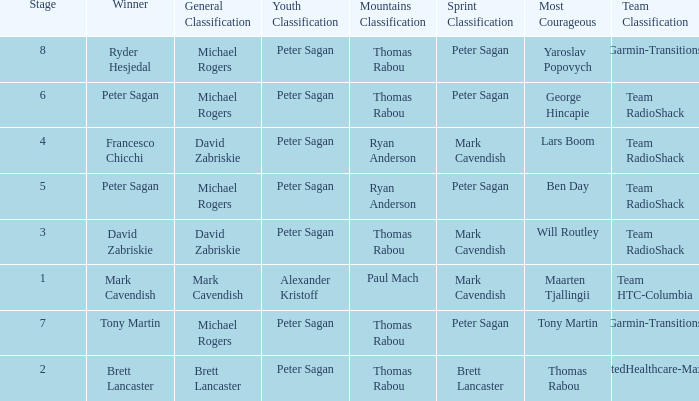Who won the mountains classification when Maarten Tjallingii won most corageous? Paul Mach. 